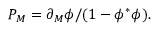Convert formula to latex. <formula><loc_0><loc_0><loc_500><loc_500>{ P _ { M } = \partial _ { M } \phi / ( 1 - \phi ^ { \ast } \phi ) . }</formula> 